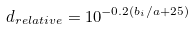Convert formula to latex. <formula><loc_0><loc_0><loc_500><loc_500>d _ { r e l a t i v e } = 1 0 ^ { - 0 . 2 ( b _ { i } / a + 2 5 ) }</formula> 